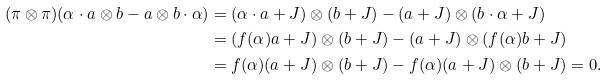<formula> <loc_0><loc_0><loc_500><loc_500>( \pi \otimes \pi ) ( \alpha \cdot a \otimes b - a \otimes b \cdot \alpha ) & = ( \alpha \cdot a + J ) \otimes ( b + J ) - ( a + J ) \otimes ( b \cdot \alpha + J ) \\ & = ( f ( \alpha ) a + J ) \otimes ( b + J ) - ( a + J ) \otimes ( f ( \alpha ) b + J ) \\ & = f ( \alpha ) ( a + J ) \otimes ( b + J ) - f ( \alpha ) ( a + J ) \otimes ( b + J ) = 0 .</formula> 